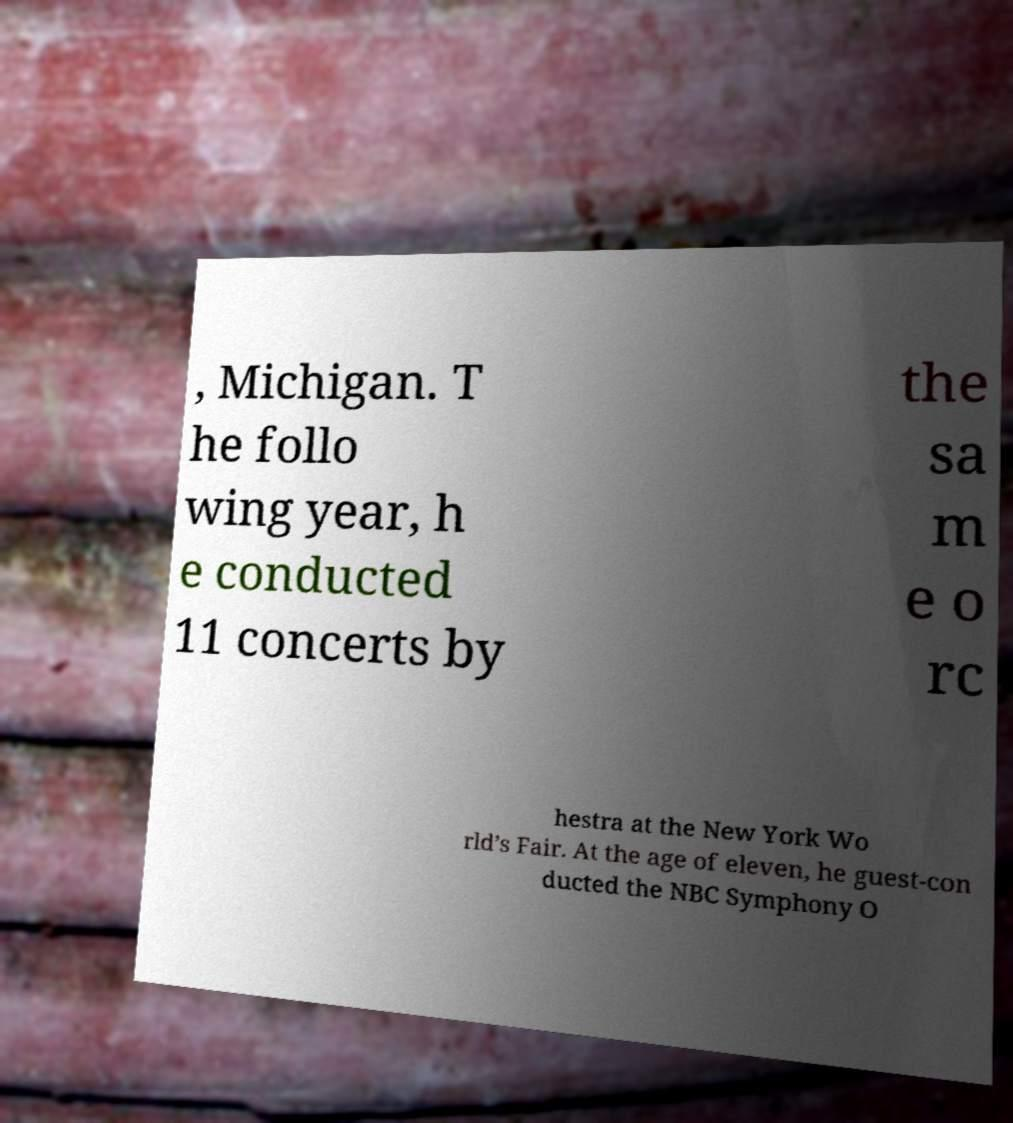What messages or text are displayed in this image? I need them in a readable, typed format. , Michigan. T he follo wing year, h e conducted 11 concerts by the sa m e o rc hestra at the New York Wo rld’s Fair. At the age of eleven, he guest-con ducted the NBC Symphony O 